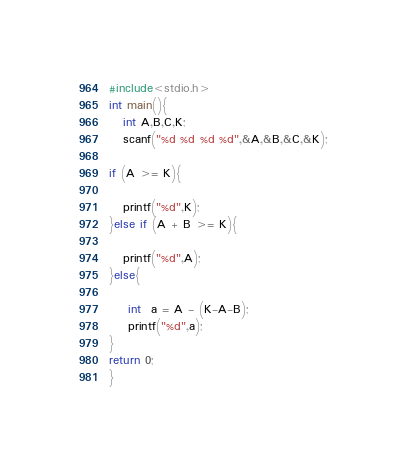<code> <loc_0><loc_0><loc_500><loc_500><_C_>#include<stdio.h>
int main(){
   int A,B,C,K;
   scanf("%d %d %d %d",&A,&B,&C,&K);

if (A >= K){

   printf("%d",K);
}else if (A + B >= K){

   printf("%d",A);
}else{
  
    int  a = A - (K-A-B);
    printf("%d",a);
}
return 0;
}
</code> 